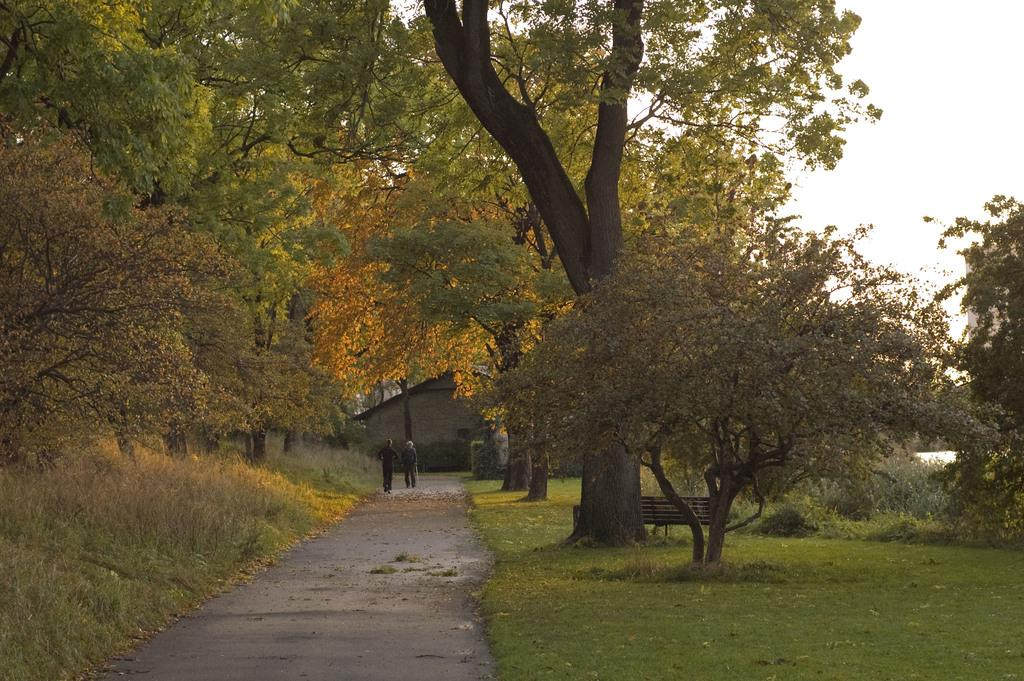What type of vegetation can be seen in the image? There are trees and plants in the image. What type of seating is available in the image? There is a bench in the image. What is on the ground in the image? There is grass on the ground in the image. What are the people in the image doing? There are people walking in the image. What can be seen in the background of the image? There is a house in the background of the image. What is the condition of the sky in the image? The sky is cloudy in the image. Can you tell me how many grains of rice are on the bench in the image? There is no rice or grains present in the image; it features trees, plants, a bench, grass, people walking, a house in the background, and a cloudy sky. Is there a lawyer sitting on the bench in the image? There is no lawyer present in the image; it features trees, plants, a bench, grass, people walking, a house in the background, and a cloudy sky. 